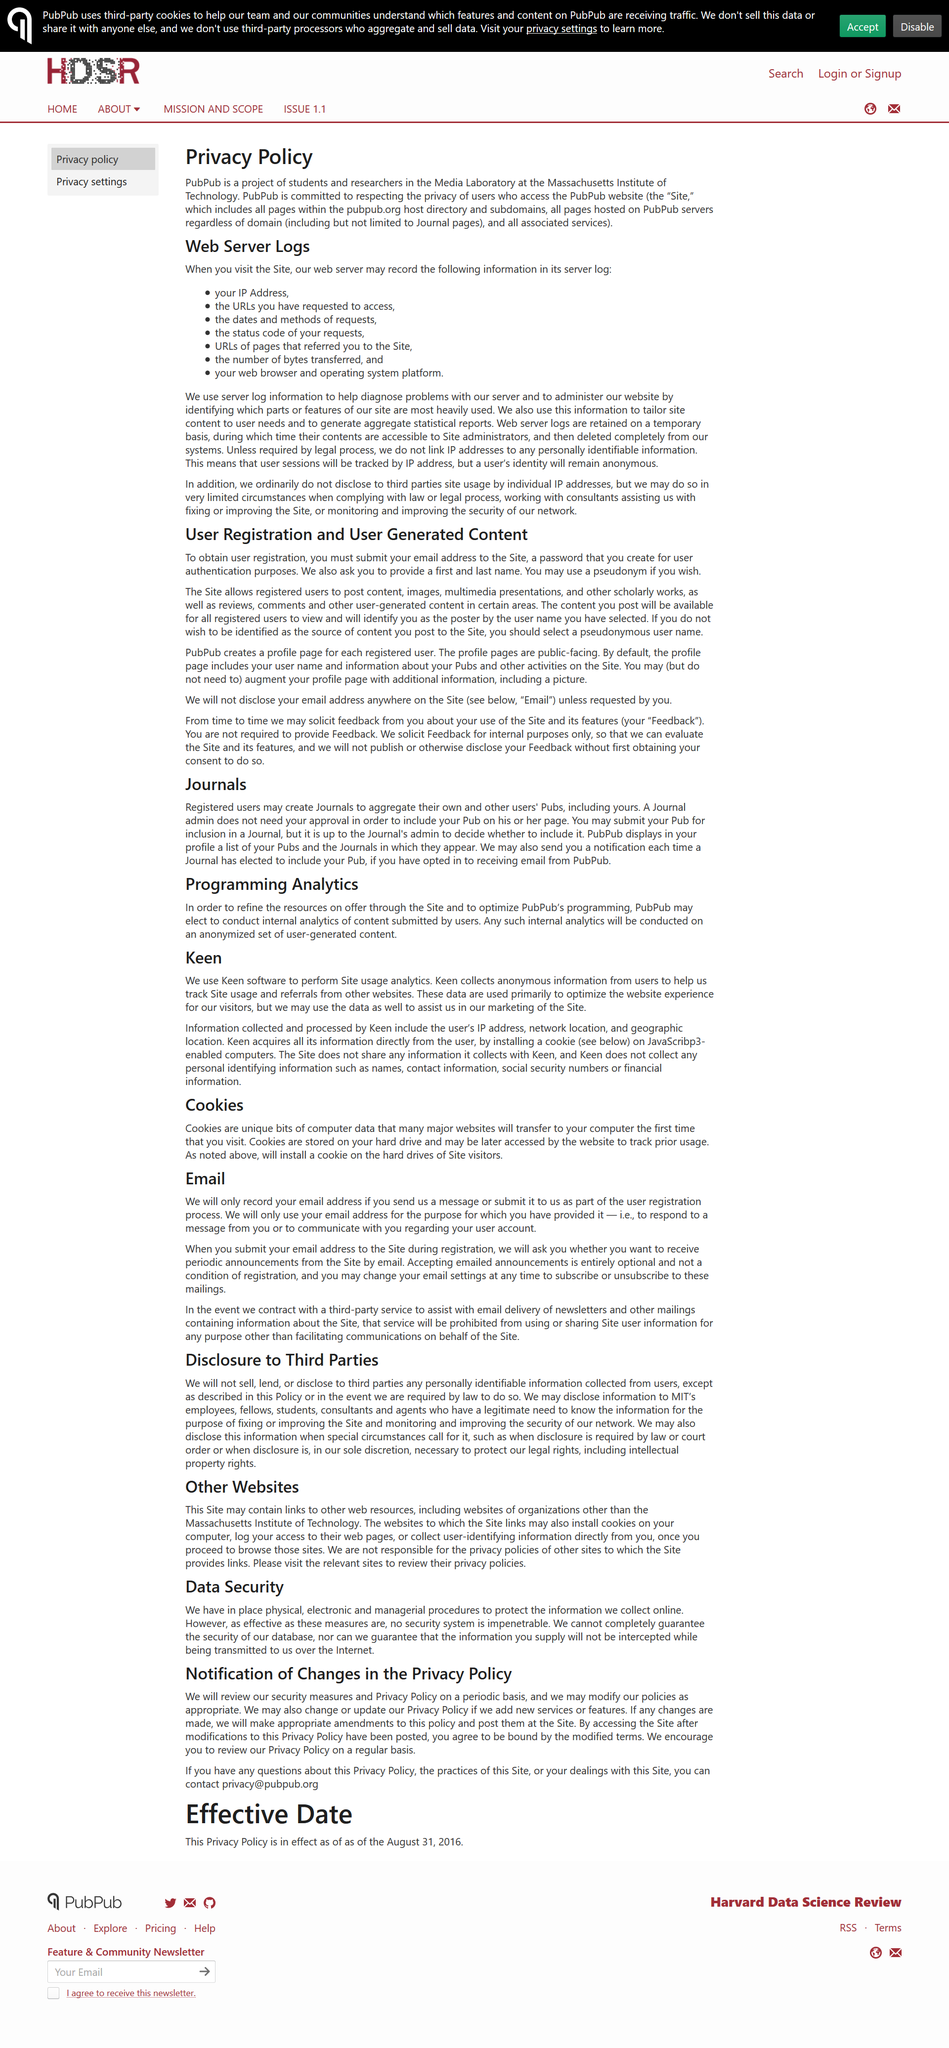Point out several critical features in this image. The policy is that accepting email announcements is entirely optional and not a condition of registration. The website can be contacted by emailing privacy@pubpub.org if questions arise regarding this Privacy Policy, the practices of the Site, or any dealings with the Site. Keen does not collect any personal identifying information. PubPub creates a profile page for each of its registered users, which contains information about the user and their activities on the platform. Keen software is used by PubPub to perform site usage analytics. 